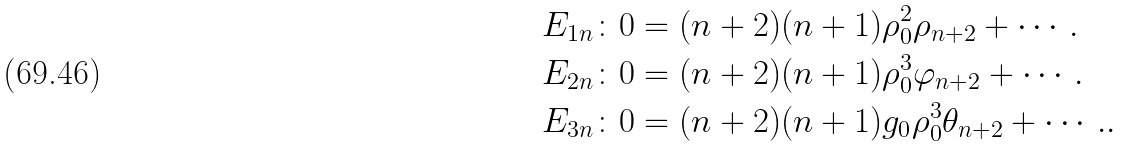<formula> <loc_0><loc_0><loc_500><loc_500>E _ { 1 n } & \colon 0 = ( n + 2 ) ( n + 1 ) \rho _ { 0 } ^ { 2 } \rho _ { n + 2 } + \cdots . \\ E _ { 2 n } & \colon 0 = ( n + 2 ) ( n + 1 ) \rho _ { 0 } ^ { 3 } \varphi _ { n + 2 } + \cdots . \\ E _ { 3 n } & \colon 0 = ( n + 2 ) ( n + 1 ) g _ { 0 } \rho _ { 0 } ^ { 3 } \theta _ { n + 2 } + \cdots . .</formula> 